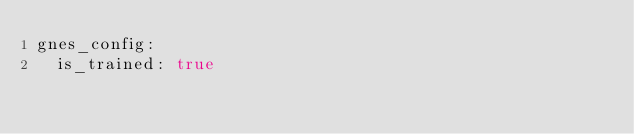<code> <loc_0><loc_0><loc_500><loc_500><_YAML_>gnes_config:
  is_trained: true</code> 